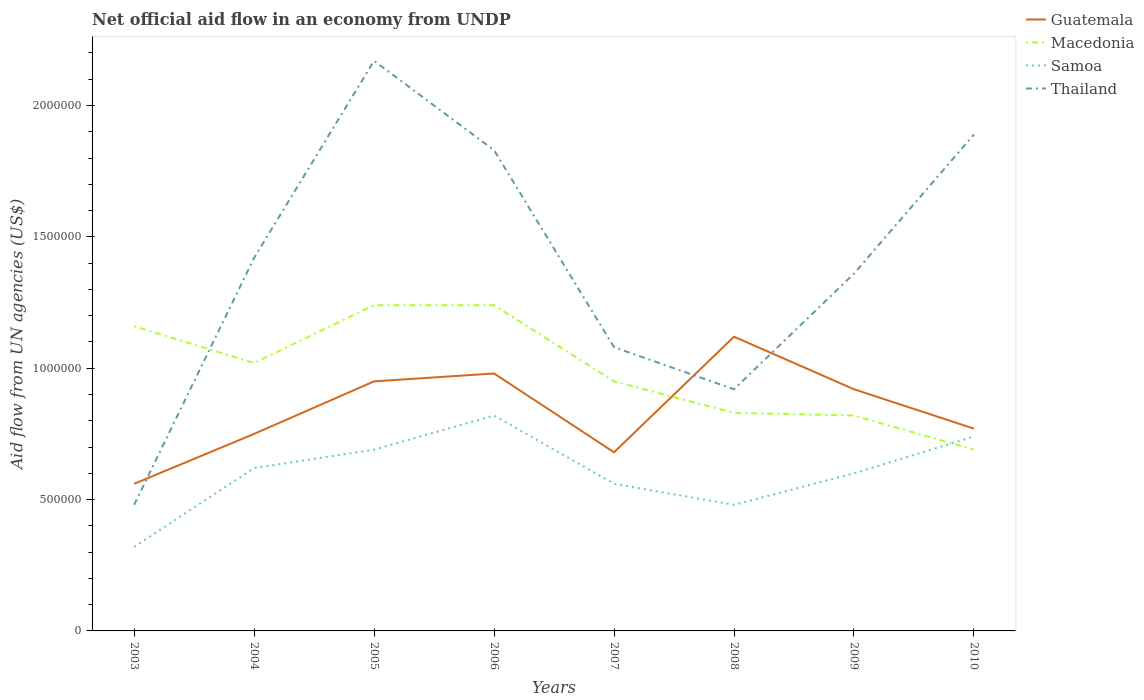Across all years, what is the maximum net official aid flow in Thailand?
Your response must be concise. 4.80e+05. In which year was the net official aid flow in Guatemala maximum?
Make the answer very short. 2003. What is the total net official aid flow in Thailand in the graph?
Your response must be concise. 8.10e+05. What is the difference between the highest and the second highest net official aid flow in Guatemala?
Your answer should be very brief. 5.60e+05. How many lines are there?
Provide a short and direct response. 4. How many years are there in the graph?
Your response must be concise. 8. Are the values on the major ticks of Y-axis written in scientific E-notation?
Offer a very short reply. No. Does the graph contain any zero values?
Provide a short and direct response. No. What is the title of the graph?
Ensure brevity in your answer.  Net official aid flow in an economy from UNDP. What is the label or title of the Y-axis?
Provide a succinct answer. Aid flow from UN agencies (US$). What is the Aid flow from UN agencies (US$) of Guatemala in 2003?
Provide a succinct answer. 5.60e+05. What is the Aid flow from UN agencies (US$) of Macedonia in 2003?
Offer a very short reply. 1.16e+06. What is the Aid flow from UN agencies (US$) of Thailand in 2003?
Offer a very short reply. 4.80e+05. What is the Aid flow from UN agencies (US$) of Guatemala in 2004?
Your answer should be compact. 7.50e+05. What is the Aid flow from UN agencies (US$) in Macedonia in 2004?
Your answer should be very brief. 1.02e+06. What is the Aid flow from UN agencies (US$) of Samoa in 2004?
Provide a succinct answer. 6.20e+05. What is the Aid flow from UN agencies (US$) of Thailand in 2004?
Provide a succinct answer. 1.42e+06. What is the Aid flow from UN agencies (US$) of Guatemala in 2005?
Your response must be concise. 9.50e+05. What is the Aid flow from UN agencies (US$) in Macedonia in 2005?
Your answer should be very brief. 1.24e+06. What is the Aid flow from UN agencies (US$) of Samoa in 2005?
Provide a succinct answer. 6.90e+05. What is the Aid flow from UN agencies (US$) in Thailand in 2005?
Provide a succinct answer. 2.17e+06. What is the Aid flow from UN agencies (US$) in Guatemala in 2006?
Ensure brevity in your answer.  9.80e+05. What is the Aid flow from UN agencies (US$) of Macedonia in 2006?
Your answer should be compact. 1.24e+06. What is the Aid flow from UN agencies (US$) of Samoa in 2006?
Keep it short and to the point. 8.20e+05. What is the Aid flow from UN agencies (US$) in Thailand in 2006?
Your response must be concise. 1.83e+06. What is the Aid flow from UN agencies (US$) in Guatemala in 2007?
Give a very brief answer. 6.80e+05. What is the Aid flow from UN agencies (US$) of Macedonia in 2007?
Your answer should be very brief. 9.50e+05. What is the Aid flow from UN agencies (US$) of Samoa in 2007?
Ensure brevity in your answer.  5.60e+05. What is the Aid flow from UN agencies (US$) in Thailand in 2007?
Offer a very short reply. 1.08e+06. What is the Aid flow from UN agencies (US$) of Guatemala in 2008?
Make the answer very short. 1.12e+06. What is the Aid flow from UN agencies (US$) in Macedonia in 2008?
Provide a succinct answer. 8.30e+05. What is the Aid flow from UN agencies (US$) in Samoa in 2008?
Make the answer very short. 4.80e+05. What is the Aid flow from UN agencies (US$) of Thailand in 2008?
Ensure brevity in your answer.  9.20e+05. What is the Aid flow from UN agencies (US$) of Guatemala in 2009?
Ensure brevity in your answer.  9.20e+05. What is the Aid flow from UN agencies (US$) in Macedonia in 2009?
Offer a very short reply. 8.20e+05. What is the Aid flow from UN agencies (US$) of Thailand in 2009?
Your answer should be very brief. 1.36e+06. What is the Aid flow from UN agencies (US$) in Guatemala in 2010?
Provide a short and direct response. 7.70e+05. What is the Aid flow from UN agencies (US$) in Macedonia in 2010?
Make the answer very short. 6.90e+05. What is the Aid flow from UN agencies (US$) in Samoa in 2010?
Offer a very short reply. 7.40e+05. What is the Aid flow from UN agencies (US$) in Thailand in 2010?
Ensure brevity in your answer.  1.89e+06. Across all years, what is the maximum Aid flow from UN agencies (US$) in Guatemala?
Ensure brevity in your answer.  1.12e+06. Across all years, what is the maximum Aid flow from UN agencies (US$) of Macedonia?
Provide a succinct answer. 1.24e+06. Across all years, what is the maximum Aid flow from UN agencies (US$) of Samoa?
Your answer should be compact. 8.20e+05. Across all years, what is the maximum Aid flow from UN agencies (US$) in Thailand?
Provide a succinct answer. 2.17e+06. Across all years, what is the minimum Aid flow from UN agencies (US$) of Guatemala?
Offer a terse response. 5.60e+05. Across all years, what is the minimum Aid flow from UN agencies (US$) in Macedonia?
Offer a terse response. 6.90e+05. Across all years, what is the minimum Aid flow from UN agencies (US$) in Samoa?
Keep it short and to the point. 3.20e+05. What is the total Aid flow from UN agencies (US$) in Guatemala in the graph?
Your answer should be very brief. 6.73e+06. What is the total Aid flow from UN agencies (US$) in Macedonia in the graph?
Offer a terse response. 7.95e+06. What is the total Aid flow from UN agencies (US$) in Samoa in the graph?
Provide a succinct answer. 4.83e+06. What is the total Aid flow from UN agencies (US$) in Thailand in the graph?
Your answer should be compact. 1.12e+07. What is the difference between the Aid flow from UN agencies (US$) in Macedonia in 2003 and that in 2004?
Give a very brief answer. 1.40e+05. What is the difference between the Aid flow from UN agencies (US$) of Samoa in 2003 and that in 2004?
Make the answer very short. -3.00e+05. What is the difference between the Aid flow from UN agencies (US$) in Thailand in 2003 and that in 2004?
Keep it short and to the point. -9.40e+05. What is the difference between the Aid flow from UN agencies (US$) of Guatemala in 2003 and that in 2005?
Offer a terse response. -3.90e+05. What is the difference between the Aid flow from UN agencies (US$) in Samoa in 2003 and that in 2005?
Ensure brevity in your answer.  -3.70e+05. What is the difference between the Aid flow from UN agencies (US$) of Thailand in 2003 and that in 2005?
Offer a terse response. -1.69e+06. What is the difference between the Aid flow from UN agencies (US$) in Guatemala in 2003 and that in 2006?
Your answer should be very brief. -4.20e+05. What is the difference between the Aid flow from UN agencies (US$) in Macedonia in 2003 and that in 2006?
Make the answer very short. -8.00e+04. What is the difference between the Aid flow from UN agencies (US$) of Samoa in 2003 and that in 2006?
Your response must be concise. -5.00e+05. What is the difference between the Aid flow from UN agencies (US$) of Thailand in 2003 and that in 2006?
Ensure brevity in your answer.  -1.35e+06. What is the difference between the Aid flow from UN agencies (US$) in Macedonia in 2003 and that in 2007?
Ensure brevity in your answer.  2.10e+05. What is the difference between the Aid flow from UN agencies (US$) of Samoa in 2003 and that in 2007?
Give a very brief answer. -2.40e+05. What is the difference between the Aid flow from UN agencies (US$) of Thailand in 2003 and that in 2007?
Make the answer very short. -6.00e+05. What is the difference between the Aid flow from UN agencies (US$) in Guatemala in 2003 and that in 2008?
Offer a very short reply. -5.60e+05. What is the difference between the Aid flow from UN agencies (US$) in Macedonia in 2003 and that in 2008?
Offer a terse response. 3.30e+05. What is the difference between the Aid flow from UN agencies (US$) in Samoa in 2003 and that in 2008?
Provide a short and direct response. -1.60e+05. What is the difference between the Aid flow from UN agencies (US$) of Thailand in 2003 and that in 2008?
Your answer should be compact. -4.40e+05. What is the difference between the Aid flow from UN agencies (US$) of Guatemala in 2003 and that in 2009?
Your response must be concise. -3.60e+05. What is the difference between the Aid flow from UN agencies (US$) of Samoa in 2003 and that in 2009?
Give a very brief answer. -2.80e+05. What is the difference between the Aid flow from UN agencies (US$) of Thailand in 2003 and that in 2009?
Your answer should be compact. -8.80e+05. What is the difference between the Aid flow from UN agencies (US$) of Guatemala in 2003 and that in 2010?
Your answer should be very brief. -2.10e+05. What is the difference between the Aid flow from UN agencies (US$) of Macedonia in 2003 and that in 2010?
Keep it short and to the point. 4.70e+05. What is the difference between the Aid flow from UN agencies (US$) of Samoa in 2003 and that in 2010?
Your answer should be very brief. -4.20e+05. What is the difference between the Aid flow from UN agencies (US$) in Thailand in 2003 and that in 2010?
Your answer should be compact. -1.41e+06. What is the difference between the Aid flow from UN agencies (US$) in Guatemala in 2004 and that in 2005?
Your response must be concise. -2.00e+05. What is the difference between the Aid flow from UN agencies (US$) in Samoa in 2004 and that in 2005?
Your response must be concise. -7.00e+04. What is the difference between the Aid flow from UN agencies (US$) of Thailand in 2004 and that in 2005?
Provide a succinct answer. -7.50e+05. What is the difference between the Aid flow from UN agencies (US$) of Thailand in 2004 and that in 2006?
Provide a succinct answer. -4.10e+05. What is the difference between the Aid flow from UN agencies (US$) of Guatemala in 2004 and that in 2008?
Provide a succinct answer. -3.70e+05. What is the difference between the Aid flow from UN agencies (US$) of Guatemala in 2004 and that in 2009?
Give a very brief answer. -1.70e+05. What is the difference between the Aid flow from UN agencies (US$) in Samoa in 2004 and that in 2010?
Keep it short and to the point. -1.20e+05. What is the difference between the Aid flow from UN agencies (US$) in Thailand in 2004 and that in 2010?
Your answer should be very brief. -4.70e+05. What is the difference between the Aid flow from UN agencies (US$) of Samoa in 2005 and that in 2006?
Give a very brief answer. -1.30e+05. What is the difference between the Aid flow from UN agencies (US$) of Thailand in 2005 and that in 2006?
Ensure brevity in your answer.  3.40e+05. What is the difference between the Aid flow from UN agencies (US$) of Guatemala in 2005 and that in 2007?
Your answer should be compact. 2.70e+05. What is the difference between the Aid flow from UN agencies (US$) of Macedonia in 2005 and that in 2007?
Provide a short and direct response. 2.90e+05. What is the difference between the Aid flow from UN agencies (US$) in Thailand in 2005 and that in 2007?
Your answer should be very brief. 1.09e+06. What is the difference between the Aid flow from UN agencies (US$) in Samoa in 2005 and that in 2008?
Keep it short and to the point. 2.10e+05. What is the difference between the Aid flow from UN agencies (US$) in Thailand in 2005 and that in 2008?
Give a very brief answer. 1.25e+06. What is the difference between the Aid flow from UN agencies (US$) of Guatemala in 2005 and that in 2009?
Provide a short and direct response. 3.00e+04. What is the difference between the Aid flow from UN agencies (US$) in Macedonia in 2005 and that in 2009?
Your answer should be compact. 4.20e+05. What is the difference between the Aid flow from UN agencies (US$) in Samoa in 2005 and that in 2009?
Give a very brief answer. 9.00e+04. What is the difference between the Aid flow from UN agencies (US$) in Thailand in 2005 and that in 2009?
Offer a terse response. 8.10e+05. What is the difference between the Aid flow from UN agencies (US$) of Guatemala in 2005 and that in 2010?
Ensure brevity in your answer.  1.80e+05. What is the difference between the Aid flow from UN agencies (US$) in Samoa in 2005 and that in 2010?
Make the answer very short. -5.00e+04. What is the difference between the Aid flow from UN agencies (US$) of Macedonia in 2006 and that in 2007?
Give a very brief answer. 2.90e+05. What is the difference between the Aid flow from UN agencies (US$) in Thailand in 2006 and that in 2007?
Your response must be concise. 7.50e+05. What is the difference between the Aid flow from UN agencies (US$) of Guatemala in 2006 and that in 2008?
Offer a very short reply. -1.40e+05. What is the difference between the Aid flow from UN agencies (US$) of Macedonia in 2006 and that in 2008?
Ensure brevity in your answer.  4.10e+05. What is the difference between the Aid flow from UN agencies (US$) in Samoa in 2006 and that in 2008?
Make the answer very short. 3.40e+05. What is the difference between the Aid flow from UN agencies (US$) in Thailand in 2006 and that in 2008?
Ensure brevity in your answer.  9.10e+05. What is the difference between the Aid flow from UN agencies (US$) in Guatemala in 2006 and that in 2009?
Offer a terse response. 6.00e+04. What is the difference between the Aid flow from UN agencies (US$) of Thailand in 2006 and that in 2009?
Your answer should be compact. 4.70e+05. What is the difference between the Aid flow from UN agencies (US$) of Macedonia in 2006 and that in 2010?
Keep it short and to the point. 5.50e+05. What is the difference between the Aid flow from UN agencies (US$) of Samoa in 2006 and that in 2010?
Make the answer very short. 8.00e+04. What is the difference between the Aid flow from UN agencies (US$) in Guatemala in 2007 and that in 2008?
Your response must be concise. -4.40e+05. What is the difference between the Aid flow from UN agencies (US$) of Thailand in 2007 and that in 2008?
Offer a very short reply. 1.60e+05. What is the difference between the Aid flow from UN agencies (US$) in Guatemala in 2007 and that in 2009?
Ensure brevity in your answer.  -2.40e+05. What is the difference between the Aid flow from UN agencies (US$) in Macedonia in 2007 and that in 2009?
Your answer should be compact. 1.30e+05. What is the difference between the Aid flow from UN agencies (US$) in Samoa in 2007 and that in 2009?
Provide a succinct answer. -4.00e+04. What is the difference between the Aid flow from UN agencies (US$) in Thailand in 2007 and that in 2009?
Your answer should be compact. -2.80e+05. What is the difference between the Aid flow from UN agencies (US$) in Macedonia in 2007 and that in 2010?
Ensure brevity in your answer.  2.60e+05. What is the difference between the Aid flow from UN agencies (US$) in Samoa in 2007 and that in 2010?
Your answer should be very brief. -1.80e+05. What is the difference between the Aid flow from UN agencies (US$) in Thailand in 2007 and that in 2010?
Provide a succinct answer. -8.10e+05. What is the difference between the Aid flow from UN agencies (US$) of Thailand in 2008 and that in 2009?
Provide a succinct answer. -4.40e+05. What is the difference between the Aid flow from UN agencies (US$) in Guatemala in 2008 and that in 2010?
Offer a terse response. 3.50e+05. What is the difference between the Aid flow from UN agencies (US$) of Macedonia in 2008 and that in 2010?
Offer a very short reply. 1.40e+05. What is the difference between the Aid flow from UN agencies (US$) in Thailand in 2008 and that in 2010?
Offer a terse response. -9.70e+05. What is the difference between the Aid flow from UN agencies (US$) in Guatemala in 2009 and that in 2010?
Ensure brevity in your answer.  1.50e+05. What is the difference between the Aid flow from UN agencies (US$) of Thailand in 2009 and that in 2010?
Provide a short and direct response. -5.30e+05. What is the difference between the Aid flow from UN agencies (US$) in Guatemala in 2003 and the Aid flow from UN agencies (US$) in Macedonia in 2004?
Make the answer very short. -4.60e+05. What is the difference between the Aid flow from UN agencies (US$) of Guatemala in 2003 and the Aid flow from UN agencies (US$) of Thailand in 2004?
Make the answer very short. -8.60e+05. What is the difference between the Aid flow from UN agencies (US$) in Macedonia in 2003 and the Aid flow from UN agencies (US$) in Samoa in 2004?
Offer a very short reply. 5.40e+05. What is the difference between the Aid flow from UN agencies (US$) of Macedonia in 2003 and the Aid flow from UN agencies (US$) of Thailand in 2004?
Provide a short and direct response. -2.60e+05. What is the difference between the Aid flow from UN agencies (US$) in Samoa in 2003 and the Aid flow from UN agencies (US$) in Thailand in 2004?
Offer a very short reply. -1.10e+06. What is the difference between the Aid flow from UN agencies (US$) in Guatemala in 2003 and the Aid flow from UN agencies (US$) in Macedonia in 2005?
Provide a succinct answer. -6.80e+05. What is the difference between the Aid flow from UN agencies (US$) in Guatemala in 2003 and the Aid flow from UN agencies (US$) in Samoa in 2005?
Ensure brevity in your answer.  -1.30e+05. What is the difference between the Aid flow from UN agencies (US$) in Guatemala in 2003 and the Aid flow from UN agencies (US$) in Thailand in 2005?
Give a very brief answer. -1.61e+06. What is the difference between the Aid flow from UN agencies (US$) in Macedonia in 2003 and the Aid flow from UN agencies (US$) in Samoa in 2005?
Your response must be concise. 4.70e+05. What is the difference between the Aid flow from UN agencies (US$) in Macedonia in 2003 and the Aid flow from UN agencies (US$) in Thailand in 2005?
Ensure brevity in your answer.  -1.01e+06. What is the difference between the Aid flow from UN agencies (US$) in Samoa in 2003 and the Aid flow from UN agencies (US$) in Thailand in 2005?
Provide a short and direct response. -1.85e+06. What is the difference between the Aid flow from UN agencies (US$) in Guatemala in 2003 and the Aid flow from UN agencies (US$) in Macedonia in 2006?
Your response must be concise. -6.80e+05. What is the difference between the Aid flow from UN agencies (US$) in Guatemala in 2003 and the Aid flow from UN agencies (US$) in Thailand in 2006?
Give a very brief answer. -1.27e+06. What is the difference between the Aid flow from UN agencies (US$) in Macedonia in 2003 and the Aid flow from UN agencies (US$) in Samoa in 2006?
Make the answer very short. 3.40e+05. What is the difference between the Aid flow from UN agencies (US$) in Macedonia in 2003 and the Aid flow from UN agencies (US$) in Thailand in 2006?
Offer a terse response. -6.70e+05. What is the difference between the Aid flow from UN agencies (US$) of Samoa in 2003 and the Aid flow from UN agencies (US$) of Thailand in 2006?
Your answer should be compact. -1.51e+06. What is the difference between the Aid flow from UN agencies (US$) in Guatemala in 2003 and the Aid flow from UN agencies (US$) in Macedonia in 2007?
Offer a terse response. -3.90e+05. What is the difference between the Aid flow from UN agencies (US$) in Guatemala in 2003 and the Aid flow from UN agencies (US$) in Samoa in 2007?
Keep it short and to the point. 0. What is the difference between the Aid flow from UN agencies (US$) of Guatemala in 2003 and the Aid flow from UN agencies (US$) of Thailand in 2007?
Ensure brevity in your answer.  -5.20e+05. What is the difference between the Aid flow from UN agencies (US$) of Macedonia in 2003 and the Aid flow from UN agencies (US$) of Samoa in 2007?
Your answer should be compact. 6.00e+05. What is the difference between the Aid flow from UN agencies (US$) of Macedonia in 2003 and the Aid flow from UN agencies (US$) of Thailand in 2007?
Give a very brief answer. 8.00e+04. What is the difference between the Aid flow from UN agencies (US$) of Samoa in 2003 and the Aid flow from UN agencies (US$) of Thailand in 2007?
Give a very brief answer. -7.60e+05. What is the difference between the Aid flow from UN agencies (US$) of Guatemala in 2003 and the Aid flow from UN agencies (US$) of Macedonia in 2008?
Ensure brevity in your answer.  -2.70e+05. What is the difference between the Aid flow from UN agencies (US$) in Guatemala in 2003 and the Aid flow from UN agencies (US$) in Thailand in 2008?
Keep it short and to the point. -3.60e+05. What is the difference between the Aid flow from UN agencies (US$) of Macedonia in 2003 and the Aid flow from UN agencies (US$) of Samoa in 2008?
Offer a terse response. 6.80e+05. What is the difference between the Aid flow from UN agencies (US$) of Macedonia in 2003 and the Aid flow from UN agencies (US$) of Thailand in 2008?
Provide a short and direct response. 2.40e+05. What is the difference between the Aid flow from UN agencies (US$) in Samoa in 2003 and the Aid flow from UN agencies (US$) in Thailand in 2008?
Offer a terse response. -6.00e+05. What is the difference between the Aid flow from UN agencies (US$) of Guatemala in 2003 and the Aid flow from UN agencies (US$) of Macedonia in 2009?
Give a very brief answer. -2.60e+05. What is the difference between the Aid flow from UN agencies (US$) in Guatemala in 2003 and the Aid flow from UN agencies (US$) in Thailand in 2009?
Your response must be concise. -8.00e+05. What is the difference between the Aid flow from UN agencies (US$) in Macedonia in 2003 and the Aid flow from UN agencies (US$) in Samoa in 2009?
Make the answer very short. 5.60e+05. What is the difference between the Aid flow from UN agencies (US$) of Macedonia in 2003 and the Aid flow from UN agencies (US$) of Thailand in 2009?
Your answer should be very brief. -2.00e+05. What is the difference between the Aid flow from UN agencies (US$) in Samoa in 2003 and the Aid flow from UN agencies (US$) in Thailand in 2009?
Your response must be concise. -1.04e+06. What is the difference between the Aid flow from UN agencies (US$) of Guatemala in 2003 and the Aid flow from UN agencies (US$) of Thailand in 2010?
Provide a short and direct response. -1.33e+06. What is the difference between the Aid flow from UN agencies (US$) of Macedonia in 2003 and the Aid flow from UN agencies (US$) of Thailand in 2010?
Make the answer very short. -7.30e+05. What is the difference between the Aid flow from UN agencies (US$) of Samoa in 2003 and the Aid flow from UN agencies (US$) of Thailand in 2010?
Make the answer very short. -1.57e+06. What is the difference between the Aid flow from UN agencies (US$) of Guatemala in 2004 and the Aid flow from UN agencies (US$) of Macedonia in 2005?
Your answer should be very brief. -4.90e+05. What is the difference between the Aid flow from UN agencies (US$) in Guatemala in 2004 and the Aid flow from UN agencies (US$) in Thailand in 2005?
Give a very brief answer. -1.42e+06. What is the difference between the Aid flow from UN agencies (US$) of Macedonia in 2004 and the Aid flow from UN agencies (US$) of Samoa in 2005?
Provide a short and direct response. 3.30e+05. What is the difference between the Aid flow from UN agencies (US$) of Macedonia in 2004 and the Aid flow from UN agencies (US$) of Thailand in 2005?
Offer a very short reply. -1.15e+06. What is the difference between the Aid flow from UN agencies (US$) of Samoa in 2004 and the Aid flow from UN agencies (US$) of Thailand in 2005?
Ensure brevity in your answer.  -1.55e+06. What is the difference between the Aid flow from UN agencies (US$) of Guatemala in 2004 and the Aid flow from UN agencies (US$) of Macedonia in 2006?
Offer a very short reply. -4.90e+05. What is the difference between the Aid flow from UN agencies (US$) of Guatemala in 2004 and the Aid flow from UN agencies (US$) of Thailand in 2006?
Make the answer very short. -1.08e+06. What is the difference between the Aid flow from UN agencies (US$) in Macedonia in 2004 and the Aid flow from UN agencies (US$) in Samoa in 2006?
Give a very brief answer. 2.00e+05. What is the difference between the Aid flow from UN agencies (US$) of Macedonia in 2004 and the Aid flow from UN agencies (US$) of Thailand in 2006?
Make the answer very short. -8.10e+05. What is the difference between the Aid flow from UN agencies (US$) in Samoa in 2004 and the Aid flow from UN agencies (US$) in Thailand in 2006?
Provide a succinct answer. -1.21e+06. What is the difference between the Aid flow from UN agencies (US$) of Guatemala in 2004 and the Aid flow from UN agencies (US$) of Macedonia in 2007?
Keep it short and to the point. -2.00e+05. What is the difference between the Aid flow from UN agencies (US$) in Guatemala in 2004 and the Aid flow from UN agencies (US$) in Thailand in 2007?
Offer a terse response. -3.30e+05. What is the difference between the Aid flow from UN agencies (US$) of Samoa in 2004 and the Aid flow from UN agencies (US$) of Thailand in 2007?
Your answer should be compact. -4.60e+05. What is the difference between the Aid flow from UN agencies (US$) of Macedonia in 2004 and the Aid flow from UN agencies (US$) of Samoa in 2008?
Offer a very short reply. 5.40e+05. What is the difference between the Aid flow from UN agencies (US$) of Macedonia in 2004 and the Aid flow from UN agencies (US$) of Thailand in 2008?
Give a very brief answer. 1.00e+05. What is the difference between the Aid flow from UN agencies (US$) in Samoa in 2004 and the Aid flow from UN agencies (US$) in Thailand in 2008?
Your answer should be very brief. -3.00e+05. What is the difference between the Aid flow from UN agencies (US$) of Guatemala in 2004 and the Aid flow from UN agencies (US$) of Macedonia in 2009?
Provide a short and direct response. -7.00e+04. What is the difference between the Aid flow from UN agencies (US$) of Guatemala in 2004 and the Aid flow from UN agencies (US$) of Samoa in 2009?
Offer a terse response. 1.50e+05. What is the difference between the Aid flow from UN agencies (US$) in Guatemala in 2004 and the Aid flow from UN agencies (US$) in Thailand in 2009?
Make the answer very short. -6.10e+05. What is the difference between the Aid flow from UN agencies (US$) in Macedonia in 2004 and the Aid flow from UN agencies (US$) in Samoa in 2009?
Offer a terse response. 4.20e+05. What is the difference between the Aid flow from UN agencies (US$) in Samoa in 2004 and the Aid flow from UN agencies (US$) in Thailand in 2009?
Ensure brevity in your answer.  -7.40e+05. What is the difference between the Aid flow from UN agencies (US$) in Guatemala in 2004 and the Aid flow from UN agencies (US$) in Samoa in 2010?
Provide a succinct answer. 10000. What is the difference between the Aid flow from UN agencies (US$) of Guatemala in 2004 and the Aid flow from UN agencies (US$) of Thailand in 2010?
Offer a terse response. -1.14e+06. What is the difference between the Aid flow from UN agencies (US$) of Macedonia in 2004 and the Aid flow from UN agencies (US$) of Thailand in 2010?
Your answer should be compact. -8.70e+05. What is the difference between the Aid flow from UN agencies (US$) of Samoa in 2004 and the Aid flow from UN agencies (US$) of Thailand in 2010?
Offer a terse response. -1.27e+06. What is the difference between the Aid flow from UN agencies (US$) in Guatemala in 2005 and the Aid flow from UN agencies (US$) in Thailand in 2006?
Offer a very short reply. -8.80e+05. What is the difference between the Aid flow from UN agencies (US$) in Macedonia in 2005 and the Aid flow from UN agencies (US$) in Thailand in 2006?
Provide a short and direct response. -5.90e+05. What is the difference between the Aid flow from UN agencies (US$) of Samoa in 2005 and the Aid flow from UN agencies (US$) of Thailand in 2006?
Give a very brief answer. -1.14e+06. What is the difference between the Aid flow from UN agencies (US$) in Guatemala in 2005 and the Aid flow from UN agencies (US$) in Samoa in 2007?
Your answer should be very brief. 3.90e+05. What is the difference between the Aid flow from UN agencies (US$) in Guatemala in 2005 and the Aid flow from UN agencies (US$) in Thailand in 2007?
Provide a succinct answer. -1.30e+05. What is the difference between the Aid flow from UN agencies (US$) in Macedonia in 2005 and the Aid flow from UN agencies (US$) in Samoa in 2007?
Your response must be concise. 6.80e+05. What is the difference between the Aid flow from UN agencies (US$) of Samoa in 2005 and the Aid flow from UN agencies (US$) of Thailand in 2007?
Give a very brief answer. -3.90e+05. What is the difference between the Aid flow from UN agencies (US$) in Guatemala in 2005 and the Aid flow from UN agencies (US$) in Macedonia in 2008?
Make the answer very short. 1.20e+05. What is the difference between the Aid flow from UN agencies (US$) of Macedonia in 2005 and the Aid flow from UN agencies (US$) of Samoa in 2008?
Your response must be concise. 7.60e+05. What is the difference between the Aid flow from UN agencies (US$) in Macedonia in 2005 and the Aid flow from UN agencies (US$) in Thailand in 2008?
Your answer should be compact. 3.20e+05. What is the difference between the Aid flow from UN agencies (US$) of Samoa in 2005 and the Aid flow from UN agencies (US$) of Thailand in 2008?
Your answer should be very brief. -2.30e+05. What is the difference between the Aid flow from UN agencies (US$) of Guatemala in 2005 and the Aid flow from UN agencies (US$) of Samoa in 2009?
Give a very brief answer. 3.50e+05. What is the difference between the Aid flow from UN agencies (US$) of Guatemala in 2005 and the Aid flow from UN agencies (US$) of Thailand in 2009?
Ensure brevity in your answer.  -4.10e+05. What is the difference between the Aid flow from UN agencies (US$) of Macedonia in 2005 and the Aid flow from UN agencies (US$) of Samoa in 2009?
Your response must be concise. 6.40e+05. What is the difference between the Aid flow from UN agencies (US$) of Macedonia in 2005 and the Aid flow from UN agencies (US$) of Thailand in 2009?
Keep it short and to the point. -1.20e+05. What is the difference between the Aid flow from UN agencies (US$) of Samoa in 2005 and the Aid flow from UN agencies (US$) of Thailand in 2009?
Make the answer very short. -6.70e+05. What is the difference between the Aid flow from UN agencies (US$) of Guatemala in 2005 and the Aid flow from UN agencies (US$) of Macedonia in 2010?
Make the answer very short. 2.60e+05. What is the difference between the Aid flow from UN agencies (US$) in Guatemala in 2005 and the Aid flow from UN agencies (US$) in Thailand in 2010?
Your answer should be very brief. -9.40e+05. What is the difference between the Aid flow from UN agencies (US$) in Macedonia in 2005 and the Aid flow from UN agencies (US$) in Samoa in 2010?
Your answer should be very brief. 5.00e+05. What is the difference between the Aid flow from UN agencies (US$) of Macedonia in 2005 and the Aid flow from UN agencies (US$) of Thailand in 2010?
Your response must be concise. -6.50e+05. What is the difference between the Aid flow from UN agencies (US$) of Samoa in 2005 and the Aid flow from UN agencies (US$) of Thailand in 2010?
Ensure brevity in your answer.  -1.20e+06. What is the difference between the Aid flow from UN agencies (US$) of Guatemala in 2006 and the Aid flow from UN agencies (US$) of Macedonia in 2007?
Your answer should be very brief. 3.00e+04. What is the difference between the Aid flow from UN agencies (US$) of Guatemala in 2006 and the Aid flow from UN agencies (US$) of Thailand in 2007?
Your answer should be compact. -1.00e+05. What is the difference between the Aid flow from UN agencies (US$) in Macedonia in 2006 and the Aid flow from UN agencies (US$) in Samoa in 2007?
Provide a short and direct response. 6.80e+05. What is the difference between the Aid flow from UN agencies (US$) of Samoa in 2006 and the Aid flow from UN agencies (US$) of Thailand in 2007?
Make the answer very short. -2.60e+05. What is the difference between the Aid flow from UN agencies (US$) in Guatemala in 2006 and the Aid flow from UN agencies (US$) in Macedonia in 2008?
Provide a succinct answer. 1.50e+05. What is the difference between the Aid flow from UN agencies (US$) in Guatemala in 2006 and the Aid flow from UN agencies (US$) in Samoa in 2008?
Your answer should be very brief. 5.00e+05. What is the difference between the Aid flow from UN agencies (US$) in Guatemala in 2006 and the Aid flow from UN agencies (US$) in Thailand in 2008?
Your answer should be compact. 6.00e+04. What is the difference between the Aid flow from UN agencies (US$) in Macedonia in 2006 and the Aid flow from UN agencies (US$) in Samoa in 2008?
Provide a short and direct response. 7.60e+05. What is the difference between the Aid flow from UN agencies (US$) in Guatemala in 2006 and the Aid flow from UN agencies (US$) in Macedonia in 2009?
Offer a very short reply. 1.60e+05. What is the difference between the Aid flow from UN agencies (US$) of Guatemala in 2006 and the Aid flow from UN agencies (US$) of Samoa in 2009?
Your answer should be compact. 3.80e+05. What is the difference between the Aid flow from UN agencies (US$) of Guatemala in 2006 and the Aid flow from UN agencies (US$) of Thailand in 2009?
Your response must be concise. -3.80e+05. What is the difference between the Aid flow from UN agencies (US$) of Macedonia in 2006 and the Aid flow from UN agencies (US$) of Samoa in 2009?
Provide a succinct answer. 6.40e+05. What is the difference between the Aid flow from UN agencies (US$) in Samoa in 2006 and the Aid flow from UN agencies (US$) in Thailand in 2009?
Keep it short and to the point. -5.40e+05. What is the difference between the Aid flow from UN agencies (US$) in Guatemala in 2006 and the Aid flow from UN agencies (US$) in Macedonia in 2010?
Your answer should be compact. 2.90e+05. What is the difference between the Aid flow from UN agencies (US$) in Guatemala in 2006 and the Aid flow from UN agencies (US$) in Thailand in 2010?
Your response must be concise. -9.10e+05. What is the difference between the Aid flow from UN agencies (US$) in Macedonia in 2006 and the Aid flow from UN agencies (US$) in Samoa in 2010?
Give a very brief answer. 5.00e+05. What is the difference between the Aid flow from UN agencies (US$) in Macedonia in 2006 and the Aid flow from UN agencies (US$) in Thailand in 2010?
Your answer should be compact. -6.50e+05. What is the difference between the Aid flow from UN agencies (US$) of Samoa in 2006 and the Aid flow from UN agencies (US$) of Thailand in 2010?
Make the answer very short. -1.07e+06. What is the difference between the Aid flow from UN agencies (US$) in Macedonia in 2007 and the Aid flow from UN agencies (US$) in Samoa in 2008?
Make the answer very short. 4.70e+05. What is the difference between the Aid flow from UN agencies (US$) in Samoa in 2007 and the Aid flow from UN agencies (US$) in Thailand in 2008?
Ensure brevity in your answer.  -3.60e+05. What is the difference between the Aid flow from UN agencies (US$) in Guatemala in 2007 and the Aid flow from UN agencies (US$) in Macedonia in 2009?
Offer a terse response. -1.40e+05. What is the difference between the Aid flow from UN agencies (US$) in Guatemala in 2007 and the Aid flow from UN agencies (US$) in Thailand in 2009?
Ensure brevity in your answer.  -6.80e+05. What is the difference between the Aid flow from UN agencies (US$) of Macedonia in 2007 and the Aid flow from UN agencies (US$) of Thailand in 2009?
Offer a terse response. -4.10e+05. What is the difference between the Aid flow from UN agencies (US$) in Samoa in 2007 and the Aid flow from UN agencies (US$) in Thailand in 2009?
Give a very brief answer. -8.00e+05. What is the difference between the Aid flow from UN agencies (US$) of Guatemala in 2007 and the Aid flow from UN agencies (US$) of Thailand in 2010?
Offer a terse response. -1.21e+06. What is the difference between the Aid flow from UN agencies (US$) of Macedonia in 2007 and the Aid flow from UN agencies (US$) of Thailand in 2010?
Your response must be concise. -9.40e+05. What is the difference between the Aid flow from UN agencies (US$) of Samoa in 2007 and the Aid flow from UN agencies (US$) of Thailand in 2010?
Provide a succinct answer. -1.33e+06. What is the difference between the Aid flow from UN agencies (US$) of Guatemala in 2008 and the Aid flow from UN agencies (US$) of Samoa in 2009?
Provide a succinct answer. 5.20e+05. What is the difference between the Aid flow from UN agencies (US$) in Macedonia in 2008 and the Aid flow from UN agencies (US$) in Samoa in 2009?
Provide a short and direct response. 2.30e+05. What is the difference between the Aid flow from UN agencies (US$) of Macedonia in 2008 and the Aid flow from UN agencies (US$) of Thailand in 2009?
Ensure brevity in your answer.  -5.30e+05. What is the difference between the Aid flow from UN agencies (US$) in Samoa in 2008 and the Aid flow from UN agencies (US$) in Thailand in 2009?
Your answer should be compact. -8.80e+05. What is the difference between the Aid flow from UN agencies (US$) of Guatemala in 2008 and the Aid flow from UN agencies (US$) of Samoa in 2010?
Offer a terse response. 3.80e+05. What is the difference between the Aid flow from UN agencies (US$) in Guatemala in 2008 and the Aid flow from UN agencies (US$) in Thailand in 2010?
Offer a terse response. -7.70e+05. What is the difference between the Aid flow from UN agencies (US$) of Macedonia in 2008 and the Aid flow from UN agencies (US$) of Thailand in 2010?
Give a very brief answer. -1.06e+06. What is the difference between the Aid flow from UN agencies (US$) of Samoa in 2008 and the Aid flow from UN agencies (US$) of Thailand in 2010?
Your answer should be very brief. -1.41e+06. What is the difference between the Aid flow from UN agencies (US$) in Guatemala in 2009 and the Aid flow from UN agencies (US$) in Macedonia in 2010?
Offer a very short reply. 2.30e+05. What is the difference between the Aid flow from UN agencies (US$) in Guatemala in 2009 and the Aid flow from UN agencies (US$) in Samoa in 2010?
Provide a succinct answer. 1.80e+05. What is the difference between the Aid flow from UN agencies (US$) in Guatemala in 2009 and the Aid flow from UN agencies (US$) in Thailand in 2010?
Ensure brevity in your answer.  -9.70e+05. What is the difference between the Aid flow from UN agencies (US$) of Macedonia in 2009 and the Aid flow from UN agencies (US$) of Thailand in 2010?
Your response must be concise. -1.07e+06. What is the difference between the Aid flow from UN agencies (US$) in Samoa in 2009 and the Aid flow from UN agencies (US$) in Thailand in 2010?
Provide a succinct answer. -1.29e+06. What is the average Aid flow from UN agencies (US$) in Guatemala per year?
Your answer should be compact. 8.41e+05. What is the average Aid flow from UN agencies (US$) of Macedonia per year?
Your response must be concise. 9.94e+05. What is the average Aid flow from UN agencies (US$) in Samoa per year?
Offer a very short reply. 6.04e+05. What is the average Aid flow from UN agencies (US$) of Thailand per year?
Give a very brief answer. 1.39e+06. In the year 2003, what is the difference between the Aid flow from UN agencies (US$) of Guatemala and Aid flow from UN agencies (US$) of Macedonia?
Ensure brevity in your answer.  -6.00e+05. In the year 2003, what is the difference between the Aid flow from UN agencies (US$) of Guatemala and Aid flow from UN agencies (US$) of Samoa?
Your answer should be very brief. 2.40e+05. In the year 2003, what is the difference between the Aid flow from UN agencies (US$) in Macedonia and Aid flow from UN agencies (US$) in Samoa?
Your response must be concise. 8.40e+05. In the year 2003, what is the difference between the Aid flow from UN agencies (US$) in Macedonia and Aid flow from UN agencies (US$) in Thailand?
Provide a short and direct response. 6.80e+05. In the year 2004, what is the difference between the Aid flow from UN agencies (US$) of Guatemala and Aid flow from UN agencies (US$) of Thailand?
Your answer should be compact. -6.70e+05. In the year 2004, what is the difference between the Aid flow from UN agencies (US$) of Macedonia and Aid flow from UN agencies (US$) of Samoa?
Ensure brevity in your answer.  4.00e+05. In the year 2004, what is the difference between the Aid flow from UN agencies (US$) of Macedonia and Aid flow from UN agencies (US$) of Thailand?
Provide a short and direct response. -4.00e+05. In the year 2004, what is the difference between the Aid flow from UN agencies (US$) of Samoa and Aid flow from UN agencies (US$) of Thailand?
Your answer should be compact. -8.00e+05. In the year 2005, what is the difference between the Aid flow from UN agencies (US$) of Guatemala and Aid flow from UN agencies (US$) of Samoa?
Your answer should be compact. 2.60e+05. In the year 2005, what is the difference between the Aid flow from UN agencies (US$) in Guatemala and Aid flow from UN agencies (US$) in Thailand?
Your answer should be very brief. -1.22e+06. In the year 2005, what is the difference between the Aid flow from UN agencies (US$) of Macedonia and Aid flow from UN agencies (US$) of Samoa?
Offer a very short reply. 5.50e+05. In the year 2005, what is the difference between the Aid flow from UN agencies (US$) in Macedonia and Aid flow from UN agencies (US$) in Thailand?
Offer a very short reply. -9.30e+05. In the year 2005, what is the difference between the Aid flow from UN agencies (US$) of Samoa and Aid flow from UN agencies (US$) of Thailand?
Provide a short and direct response. -1.48e+06. In the year 2006, what is the difference between the Aid flow from UN agencies (US$) of Guatemala and Aid flow from UN agencies (US$) of Macedonia?
Ensure brevity in your answer.  -2.60e+05. In the year 2006, what is the difference between the Aid flow from UN agencies (US$) in Guatemala and Aid flow from UN agencies (US$) in Thailand?
Your answer should be compact. -8.50e+05. In the year 2006, what is the difference between the Aid flow from UN agencies (US$) in Macedonia and Aid flow from UN agencies (US$) in Samoa?
Offer a terse response. 4.20e+05. In the year 2006, what is the difference between the Aid flow from UN agencies (US$) in Macedonia and Aid flow from UN agencies (US$) in Thailand?
Offer a terse response. -5.90e+05. In the year 2006, what is the difference between the Aid flow from UN agencies (US$) of Samoa and Aid flow from UN agencies (US$) of Thailand?
Offer a terse response. -1.01e+06. In the year 2007, what is the difference between the Aid flow from UN agencies (US$) in Guatemala and Aid flow from UN agencies (US$) in Macedonia?
Offer a very short reply. -2.70e+05. In the year 2007, what is the difference between the Aid flow from UN agencies (US$) of Guatemala and Aid flow from UN agencies (US$) of Samoa?
Keep it short and to the point. 1.20e+05. In the year 2007, what is the difference between the Aid flow from UN agencies (US$) in Guatemala and Aid flow from UN agencies (US$) in Thailand?
Make the answer very short. -4.00e+05. In the year 2007, what is the difference between the Aid flow from UN agencies (US$) of Samoa and Aid flow from UN agencies (US$) of Thailand?
Your response must be concise. -5.20e+05. In the year 2008, what is the difference between the Aid flow from UN agencies (US$) in Guatemala and Aid flow from UN agencies (US$) in Samoa?
Your answer should be compact. 6.40e+05. In the year 2008, what is the difference between the Aid flow from UN agencies (US$) of Samoa and Aid flow from UN agencies (US$) of Thailand?
Give a very brief answer. -4.40e+05. In the year 2009, what is the difference between the Aid flow from UN agencies (US$) in Guatemala and Aid flow from UN agencies (US$) in Thailand?
Your answer should be compact. -4.40e+05. In the year 2009, what is the difference between the Aid flow from UN agencies (US$) in Macedonia and Aid flow from UN agencies (US$) in Thailand?
Give a very brief answer. -5.40e+05. In the year 2009, what is the difference between the Aid flow from UN agencies (US$) of Samoa and Aid flow from UN agencies (US$) of Thailand?
Your response must be concise. -7.60e+05. In the year 2010, what is the difference between the Aid flow from UN agencies (US$) of Guatemala and Aid flow from UN agencies (US$) of Macedonia?
Provide a succinct answer. 8.00e+04. In the year 2010, what is the difference between the Aid flow from UN agencies (US$) of Guatemala and Aid flow from UN agencies (US$) of Samoa?
Keep it short and to the point. 3.00e+04. In the year 2010, what is the difference between the Aid flow from UN agencies (US$) in Guatemala and Aid flow from UN agencies (US$) in Thailand?
Your answer should be compact. -1.12e+06. In the year 2010, what is the difference between the Aid flow from UN agencies (US$) in Macedonia and Aid flow from UN agencies (US$) in Thailand?
Your answer should be compact. -1.20e+06. In the year 2010, what is the difference between the Aid flow from UN agencies (US$) of Samoa and Aid flow from UN agencies (US$) of Thailand?
Offer a terse response. -1.15e+06. What is the ratio of the Aid flow from UN agencies (US$) of Guatemala in 2003 to that in 2004?
Your answer should be very brief. 0.75. What is the ratio of the Aid flow from UN agencies (US$) in Macedonia in 2003 to that in 2004?
Give a very brief answer. 1.14. What is the ratio of the Aid flow from UN agencies (US$) in Samoa in 2003 to that in 2004?
Provide a short and direct response. 0.52. What is the ratio of the Aid flow from UN agencies (US$) in Thailand in 2003 to that in 2004?
Provide a short and direct response. 0.34. What is the ratio of the Aid flow from UN agencies (US$) of Guatemala in 2003 to that in 2005?
Make the answer very short. 0.59. What is the ratio of the Aid flow from UN agencies (US$) of Macedonia in 2003 to that in 2005?
Offer a terse response. 0.94. What is the ratio of the Aid flow from UN agencies (US$) of Samoa in 2003 to that in 2005?
Ensure brevity in your answer.  0.46. What is the ratio of the Aid flow from UN agencies (US$) in Thailand in 2003 to that in 2005?
Your answer should be compact. 0.22. What is the ratio of the Aid flow from UN agencies (US$) in Guatemala in 2003 to that in 2006?
Give a very brief answer. 0.57. What is the ratio of the Aid flow from UN agencies (US$) in Macedonia in 2003 to that in 2006?
Ensure brevity in your answer.  0.94. What is the ratio of the Aid flow from UN agencies (US$) in Samoa in 2003 to that in 2006?
Your response must be concise. 0.39. What is the ratio of the Aid flow from UN agencies (US$) in Thailand in 2003 to that in 2006?
Your response must be concise. 0.26. What is the ratio of the Aid flow from UN agencies (US$) of Guatemala in 2003 to that in 2007?
Offer a very short reply. 0.82. What is the ratio of the Aid flow from UN agencies (US$) of Macedonia in 2003 to that in 2007?
Your answer should be compact. 1.22. What is the ratio of the Aid flow from UN agencies (US$) of Samoa in 2003 to that in 2007?
Make the answer very short. 0.57. What is the ratio of the Aid flow from UN agencies (US$) in Thailand in 2003 to that in 2007?
Make the answer very short. 0.44. What is the ratio of the Aid flow from UN agencies (US$) of Guatemala in 2003 to that in 2008?
Offer a terse response. 0.5. What is the ratio of the Aid flow from UN agencies (US$) in Macedonia in 2003 to that in 2008?
Provide a short and direct response. 1.4. What is the ratio of the Aid flow from UN agencies (US$) in Samoa in 2003 to that in 2008?
Your answer should be very brief. 0.67. What is the ratio of the Aid flow from UN agencies (US$) in Thailand in 2003 to that in 2008?
Provide a succinct answer. 0.52. What is the ratio of the Aid flow from UN agencies (US$) of Guatemala in 2003 to that in 2009?
Make the answer very short. 0.61. What is the ratio of the Aid flow from UN agencies (US$) in Macedonia in 2003 to that in 2009?
Make the answer very short. 1.41. What is the ratio of the Aid flow from UN agencies (US$) of Samoa in 2003 to that in 2009?
Offer a very short reply. 0.53. What is the ratio of the Aid flow from UN agencies (US$) in Thailand in 2003 to that in 2009?
Keep it short and to the point. 0.35. What is the ratio of the Aid flow from UN agencies (US$) in Guatemala in 2003 to that in 2010?
Provide a succinct answer. 0.73. What is the ratio of the Aid flow from UN agencies (US$) in Macedonia in 2003 to that in 2010?
Keep it short and to the point. 1.68. What is the ratio of the Aid flow from UN agencies (US$) of Samoa in 2003 to that in 2010?
Provide a short and direct response. 0.43. What is the ratio of the Aid flow from UN agencies (US$) in Thailand in 2003 to that in 2010?
Give a very brief answer. 0.25. What is the ratio of the Aid flow from UN agencies (US$) in Guatemala in 2004 to that in 2005?
Provide a short and direct response. 0.79. What is the ratio of the Aid flow from UN agencies (US$) of Macedonia in 2004 to that in 2005?
Your answer should be compact. 0.82. What is the ratio of the Aid flow from UN agencies (US$) of Samoa in 2004 to that in 2005?
Your answer should be compact. 0.9. What is the ratio of the Aid flow from UN agencies (US$) in Thailand in 2004 to that in 2005?
Ensure brevity in your answer.  0.65. What is the ratio of the Aid flow from UN agencies (US$) in Guatemala in 2004 to that in 2006?
Your response must be concise. 0.77. What is the ratio of the Aid flow from UN agencies (US$) of Macedonia in 2004 to that in 2006?
Offer a terse response. 0.82. What is the ratio of the Aid flow from UN agencies (US$) of Samoa in 2004 to that in 2006?
Offer a terse response. 0.76. What is the ratio of the Aid flow from UN agencies (US$) in Thailand in 2004 to that in 2006?
Offer a very short reply. 0.78. What is the ratio of the Aid flow from UN agencies (US$) of Guatemala in 2004 to that in 2007?
Provide a succinct answer. 1.1. What is the ratio of the Aid flow from UN agencies (US$) in Macedonia in 2004 to that in 2007?
Provide a short and direct response. 1.07. What is the ratio of the Aid flow from UN agencies (US$) of Samoa in 2004 to that in 2007?
Your answer should be very brief. 1.11. What is the ratio of the Aid flow from UN agencies (US$) in Thailand in 2004 to that in 2007?
Offer a very short reply. 1.31. What is the ratio of the Aid flow from UN agencies (US$) in Guatemala in 2004 to that in 2008?
Your response must be concise. 0.67. What is the ratio of the Aid flow from UN agencies (US$) in Macedonia in 2004 to that in 2008?
Offer a terse response. 1.23. What is the ratio of the Aid flow from UN agencies (US$) in Samoa in 2004 to that in 2008?
Offer a terse response. 1.29. What is the ratio of the Aid flow from UN agencies (US$) in Thailand in 2004 to that in 2008?
Provide a succinct answer. 1.54. What is the ratio of the Aid flow from UN agencies (US$) of Guatemala in 2004 to that in 2009?
Offer a terse response. 0.82. What is the ratio of the Aid flow from UN agencies (US$) in Macedonia in 2004 to that in 2009?
Provide a short and direct response. 1.24. What is the ratio of the Aid flow from UN agencies (US$) of Samoa in 2004 to that in 2009?
Your answer should be very brief. 1.03. What is the ratio of the Aid flow from UN agencies (US$) in Thailand in 2004 to that in 2009?
Keep it short and to the point. 1.04. What is the ratio of the Aid flow from UN agencies (US$) of Macedonia in 2004 to that in 2010?
Keep it short and to the point. 1.48. What is the ratio of the Aid flow from UN agencies (US$) in Samoa in 2004 to that in 2010?
Make the answer very short. 0.84. What is the ratio of the Aid flow from UN agencies (US$) of Thailand in 2004 to that in 2010?
Keep it short and to the point. 0.75. What is the ratio of the Aid flow from UN agencies (US$) of Guatemala in 2005 to that in 2006?
Provide a succinct answer. 0.97. What is the ratio of the Aid flow from UN agencies (US$) of Macedonia in 2005 to that in 2006?
Keep it short and to the point. 1. What is the ratio of the Aid flow from UN agencies (US$) in Samoa in 2005 to that in 2006?
Give a very brief answer. 0.84. What is the ratio of the Aid flow from UN agencies (US$) of Thailand in 2005 to that in 2006?
Keep it short and to the point. 1.19. What is the ratio of the Aid flow from UN agencies (US$) of Guatemala in 2005 to that in 2007?
Give a very brief answer. 1.4. What is the ratio of the Aid flow from UN agencies (US$) in Macedonia in 2005 to that in 2007?
Your response must be concise. 1.31. What is the ratio of the Aid flow from UN agencies (US$) in Samoa in 2005 to that in 2007?
Offer a very short reply. 1.23. What is the ratio of the Aid flow from UN agencies (US$) in Thailand in 2005 to that in 2007?
Your answer should be very brief. 2.01. What is the ratio of the Aid flow from UN agencies (US$) of Guatemala in 2005 to that in 2008?
Make the answer very short. 0.85. What is the ratio of the Aid flow from UN agencies (US$) of Macedonia in 2005 to that in 2008?
Your response must be concise. 1.49. What is the ratio of the Aid flow from UN agencies (US$) in Samoa in 2005 to that in 2008?
Give a very brief answer. 1.44. What is the ratio of the Aid flow from UN agencies (US$) of Thailand in 2005 to that in 2008?
Provide a succinct answer. 2.36. What is the ratio of the Aid flow from UN agencies (US$) in Guatemala in 2005 to that in 2009?
Ensure brevity in your answer.  1.03. What is the ratio of the Aid flow from UN agencies (US$) in Macedonia in 2005 to that in 2009?
Give a very brief answer. 1.51. What is the ratio of the Aid flow from UN agencies (US$) of Samoa in 2005 to that in 2009?
Keep it short and to the point. 1.15. What is the ratio of the Aid flow from UN agencies (US$) of Thailand in 2005 to that in 2009?
Your response must be concise. 1.6. What is the ratio of the Aid flow from UN agencies (US$) in Guatemala in 2005 to that in 2010?
Your response must be concise. 1.23. What is the ratio of the Aid flow from UN agencies (US$) of Macedonia in 2005 to that in 2010?
Give a very brief answer. 1.8. What is the ratio of the Aid flow from UN agencies (US$) of Samoa in 2005 to that in 2010?
Make the answer very short. 0.93. What is the ratio of the Aid flow from UN agencies (US$) of Thailand in 2005 to that in 2010?
Ensure brevity in your answer.  1.15. What is the ratio of the Aid flow from UN agencies (US$) of Guatemala in 2006 to that in 2007?
Your answer should be compact. 1.44. What is the ratio of the Aid flow from UN agencies (US$) of Macedonia in 2006 to that in 2007?
Offer a very short reply. 1.31. What is the ratio of the Aid flow from UN agencies (US$) in Samoa in 2006 to that in 2007?
Give a very brief answer. 1.46. What is the ratio of the Aid flow from UN agencies (US$) in Thailand in 2006 to that in 2007?
Make the answer very short. 1.69. What is the ratio of the Aid flow from UN agencies (US$) of Guatemala in 2006 to that in 2008?
Make the answer very short. 0.88. What is the ratio of the Aid flow from UN agencies (US$) of Macedonia in 2006 to that in 2008?
Your answer should be compact. 1.49. What is the ratio of the Aid flow from UN agencies (US$) in Samoa in 2006 to that in 2008?
Provide a succinct answer. 1.71. What is the ratio of the Aid flow from UN agencies (US$) of Thailand in 2006 to that in 2008?
Your answer should be very brief. 1.99. What is the ratio of the Aid flow from UN agencies (US$) in Guatemala in 2006 to that in 2009?
Offer a terse response. 1.07. What is the ratio of the Aid flow from UN agencies (US$) in Macedonia in 2006 to that in 2009?
Ensure brevity in your answer.  1.51. What is the ratio of the Aid flow from UN agencies (US$) in Samoa in 2006 to that in 2009?
Offer a terse response. 1.37. What is the ratio of the Aid flow from UN agencies (US$) in Thailand in 2006 to that in 2009?
Provide a short and direct response. 1.35. What is the ratio of the Aid flow from UN agencies (US$) in Guatemala in 2006 to that in 2010?
Offer a terse response. 1.27. What is the ratio of the Aid flow from UN agencies (US$) of Macedonia in 2006 to that in 2010?
Your answer should be compact. 1.8. What is the ratio of the Aid flow from UN agencies (US$) of Samoa in 2006 to that in 2010?
Offer a terse response. 1.11. What is the ratio of the Aid flow from UN agencies (US$) in Thailand in 2006 to that in 2010?
Provide a succinct answer. 0.97. What is the ratio of the Aid flow from UN agencies (US$) in Guatemala in 2007 to that in 2008?
Ensure brevity in your answer.  0.61. What is the ratio of the Aid flow from UN agencies (US$) in Macedonia in 2007 to that in 2008?
Provide a short and direct response. 1.14. What is the ratio of the Aid flow from UN agencies (US$) in Samoa in 2007 to that in 2008?
Offer a terse response. 1.17. What is the ratio of the Aid flow from UN agencies (US$) in Thailand in 2007 to that in 2008?
Offer a very short reply. 1.17. What is the ratio of the Aid flow from UN agencies (US$) in Guatemala in 2007 to that in 2009?
Ensure brevity in your answer.  0.74. What is the ratio of the Aid flow from UN agencies (US$) of Macedonia in 2007 to that in 2009?
Offer a terse response. 1.16. What is the ratio of the Aid flow from UN agencies (US$) of Thailand in 2007 to that in 2009?
Offer a very short reply. 0.79. What is the ratio of the Aid flow from UN agencies (US$) in Guatemala in 2007 to that in 2010?
Give a very brief answer. 0.88. What is the ratio of the Aid flow from UN agencies (US$) of Macedonia in 2007 to that in 2010?
Provide a short and direct response. 1.38. What is the ratio of the Aid flow from UN agencies (US$) of Samoa in 2007 to that in 2010?
Provide a succinct answer. 0.76. What is the ratio of the Aid flow from UN agencies (US$) of Thailand in 2007 to that in 2010?
Provide a succinct answer. 0.57. What is the ratio of the Aid flow from UN agencies (US$) in Guatemala in 2008 to that in 2009?
Offer a very short reply. 1.22. What is the ratio of the Aid flow from UN agencies (US$) in Macedonia in 2008 to that in 2009?
Your answer should be compact. 1.01. What is the ratio of the Aid flow from UN agencies (US$) in Thailand in 2008 to that in 2009?
Your answer should be very brief. 0.68. What is the ratio of the Aid flow from UN agencies (US$) of Guatemala in 2008 to that in 2010?
Provide a succinct answer. 1.45. What is the ratio of the Aid flow from UN agencies (US$) in Macedonia in 2008 to that in 2010?
Provide a short and direct response. 1.2. What is the ratio of the Aid flow from UN agencies (US$) of Samoa in 2008 to that in 2010?
Provide a succinct answer. 0.65. What is the ratio of the Aid flow from UN agencies (US$) in Thailand in 2008 to that in 2010?
Keep it short and to the point. 0.49. What is the ratio of the Aid flow from UN agencies (US$) in Guatemala in 2009 to that in 2010?
Your answer should be very brief. 1.19. What is the ratio of the Aid flow from UN agencies (US$) of Macedonia in 2009 to that in 2010?
Offer a terse response. 1.19. What is the ratio of the Aid flow from UN agencies (US$) of Samoa in 2009 to that in 2010?
Give a very brief answer. 0.81. What is the ratio of the Aid flow from UN agencies (US$) of Thailand in 2009 to that in 2010?
Give a very brief answer. 0.72. What is the difference between the highest and the second highest Aid flow from UN agencies (US$) of Guatemala?
Keep it short and to the point. 1.40e+05. What is the difference between the highest and the second highest Aid flow from UN agencies (US$) in Macedonia?
Offer a terse response. 0. What is the difference between the highest and the lowest Aid flow from UN agencies (US$) of Guatemala?
Your response must be concise. 5.60e+05. What is the difference between the highest and the lowest Aid flow from UN agencies (US$) in Samoa?
Give a very brief answer. 5.00e+05. What is the difference between the highest and the lowest Aid flow from UN agencies (US$) of Thailand?
Give a very brief answer. 1.69e+06. 